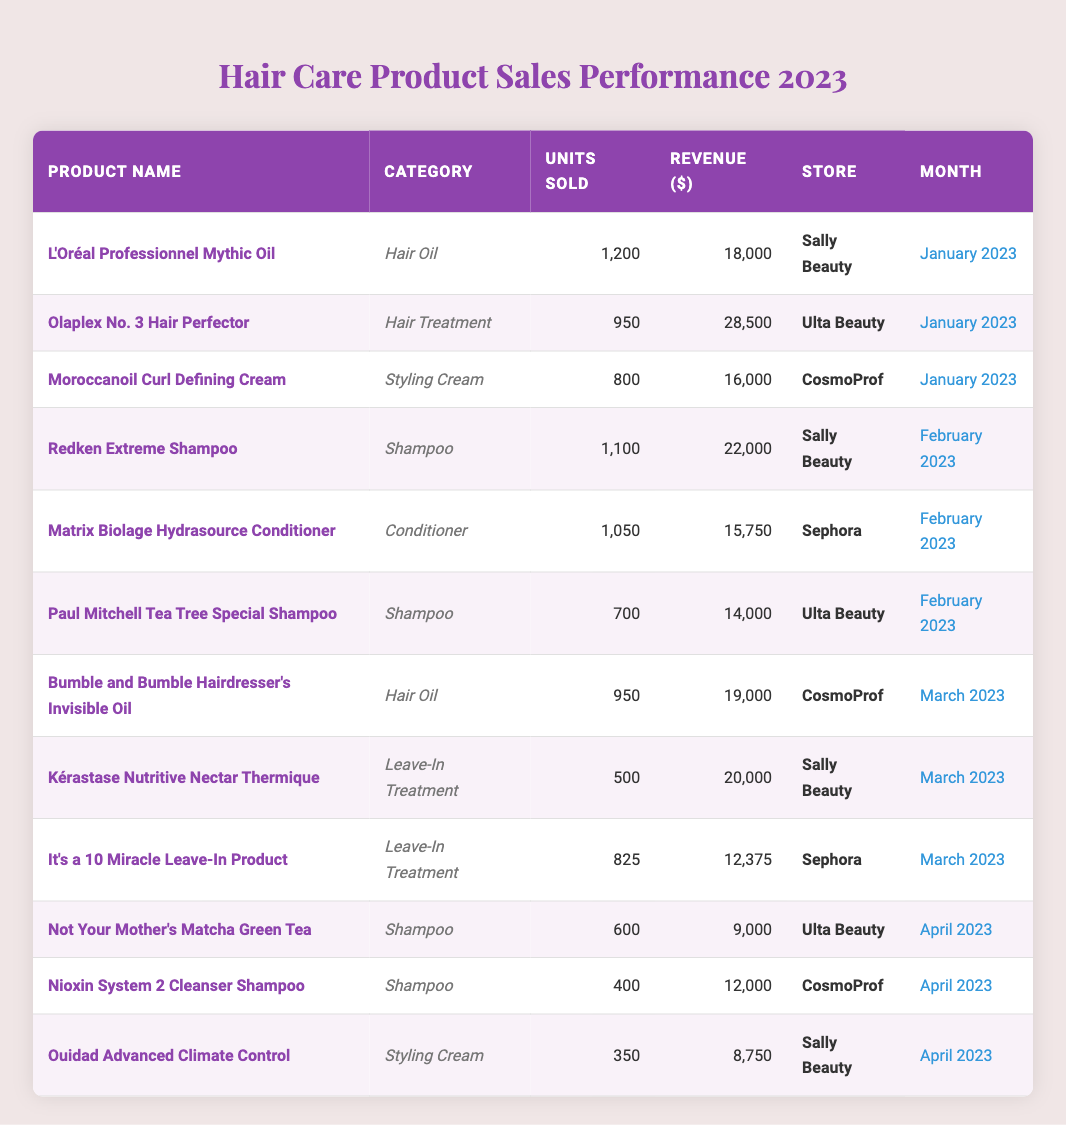What is the total revenue generated from the sales of "Olaplex No. 3 Hair Perfector"? The table indicates that "Olaplex No. 3 Hair Perfector" generated revenue of $28,500 in January 2023.
Answer: $28,500 Which product had the highest units sold in February 2023? In February 2023, "Redken Extreme Shampoo" sold 1,100 units, which is more than any other product in that month.
Answer: Redken Extreme Shampoo What is the average revenue of hair oil products sold? The hair oil products listed are "L'Oréal Professionnel Mythic Oil" with $18,000 revenue and "Bumble and Bumble Hairdresser’s Invisible Oil" with $19,000 revenue. Their total revenue is $37,000, and there are 2 products, so the average is $37,000 / 2 = $18,500.
Answer: $18,500 Which store sold the least number of units across all products? Reviewing the data, "Ouidad Advanced Climate Control" sold 350 units at Sally Beauty, which is the lowest compared to other products in the table.
Answer: Sally Beauty Did "Nioxin System 2 Cleanser Shampoo" generate more revenue than "Not Your Mother's Matcha Green Tea"? "Nioxin System 2 Cleanser Shampoo" generated $12,000 while "Not Your Mother's Matcha Green Tea" generated $9,000, so yes, it generated more revenue.
Answer: Yes What is the percentage of total units sold that "Paul Mitchell Tea Tree Special Shampoo" accounted for in February 2023? The total units sold in February is 1,100 (Redken) + 1,050 (Matrix Biolage) + 700 (Paul Mitchell) = 2,850. Paul Mitchell sold 700 units, so the percentage is (700 / 2850) * 100 = 24.56%.
Answer: 24.56% What was the total revenue from all shampoo products sold in the first four months? Adding the revenue from Redken ($22,000), Paul Mitchell ($14,000), Not Your Mother's ($9,000), and Nioxin ($12,000) gives $22,000 + $14,000 + $9,000 + $12,000 = $57,000.
Answer: $57,000 Was there a product that sold over 1,000 units in March 2023? In March 2023, "Bumble and Bumble Hairdresser's Invisible Oil" sold 950 units and "Kérastase Nutritive Nectar Thermique" sold 500 units, both below 1,000, thus no product sold over 1,000 units.
Answer: No Which product had the highest revenue in January 2023? In January 2023, "Olaplex No. 3 Hair Perfector" earned the highest revenue of $28,500 compared to other products listed for that month.
Answer: Olaplex No. 3 Hair Perfector How many different categories of products are represented in the data? The categories present are Hair Oil, Hair Treatment, Styling Cream, Shampoo, Conditioner, and Leave-In Treatment, which totals to 6 different categories.
Answer: 6 What is the comparison of average units sold between the Shampoo and Styling Cream categories? The average units sold for Shampoo (Redken - 1,100; Paul Mitchell - 700; Not Your Mother’s - 600; Nioxin - 400) is (1,100 + 700 + 600 + 400) / 4 = 715. The average for Styling Cream (Moroccanoil - 800; Ouidad - 350; Bumble and Bumble - 950) is (800 + 950 + 350) / 3 = 700. Thus, Shampoo sold more units on average than Styling Cream.
Answer: Shampoo has a higher average 